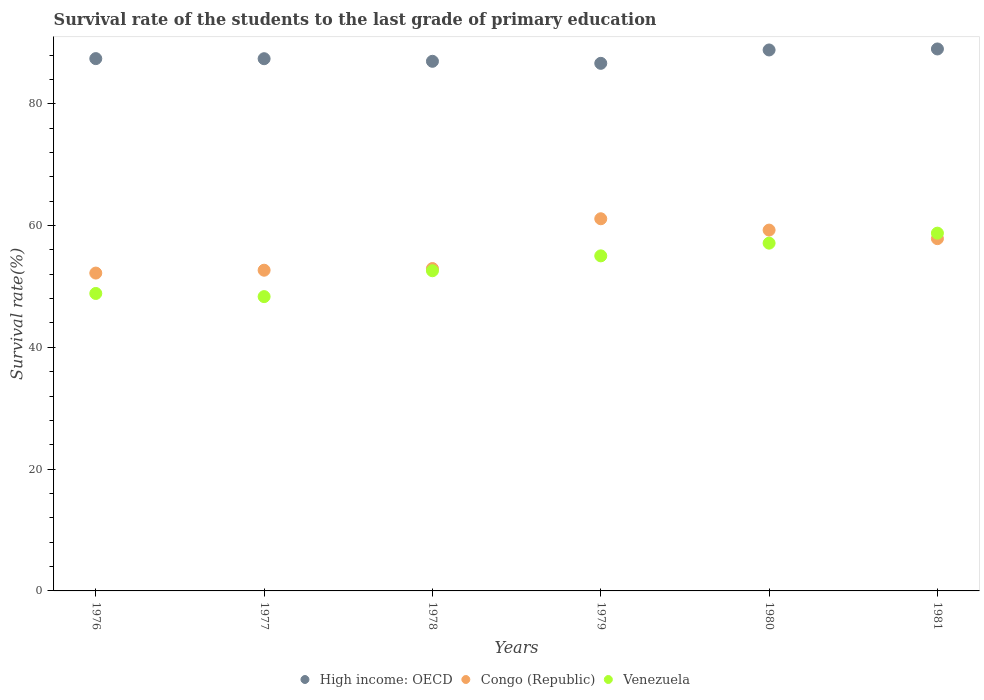How many different coloured dotlines are there?
Make the answer very short. 3. Is the number of dotlines equal to the number of legend labels?
Offer a terse response. Yes. What is the survival rate of the students in Congo (Republic) in 1978?
Ensure brevity in your answer.  52.94. Across all years, what is the maximum survival rate of the students in Congo (Republic)?
Ensure brevity in your answer.  61.11. Across all years, what is the minimum survival rate of the students in Venezuela?
Your response must be concise. 48.33. In which year was the survival rate of the students in Venezuela maximum?
Your response must be concise. 1981. In which year was the survival rate of the students in High income: OECD minimum?
Give a very brief answer. 1979. What is the total survival rate of the students in Congo (Republic) in the graph?
Provide a short and direct response. 336. What is the difference between the survival rate of the students in High income: OECD in 1978 and that in 1980?
Make the answer very short. -1.86. What is the difference between the survival rate of the students in High income: OECD in 1981 and the survival rate of the students in Congo (Republic) in 1978?
Ensure brevity in your answer.  36.06. What is the average survival rate of the students in Venezuela per year?
Your answer should be very brief. 53.44. In the year 1976, what is the difference between the survival rate of the students in Congo (Republic) and survival rate of the students in High income: OECD?
Make the answer very short. -35.22. In how many years, is the survival rate of the students in Congo (Republic) greater than 76 %?
Give a very brief answer. 0. What is the ratio of the survival rate of the students in Congo (Republic) in 1978 to that in 1980?
Offer a terse response. 0.89. Is the survival rate of the students in Congo (Republic) in 1977 less than that in 1979?
Provide a short and direct response. Yes. What is the difference between the highest and the second highest survival rate of the students in Venezuela?
Offer a very short reply. 1.64. What is the difference between the highest and the lowest survival rate of the students in Venezuela?
Your answer should be very brief. 10.42. In how many years, is the survival rate of the students in High income: OECD greater than the average survival rate of the students in High income: OECD taken over all years?
Provide a succinct answer. 2. Is the sum of the survival rate of the students in Venezuela in 1979 and 1981 greater than the maximum survival rate of the students in High income: OECD across all years?
Your answer should be compact. Yes. Is it the case that in every year, the sum of the survival rate of the students in Venezuela and survival rate of the students in Congo (Republic)  is greater than the survival rate of the students in High income: OECD?
Your answer should be very brief. Yes. Is the survival rate of the students in Congo (Republic) strictly less than the survival rate of the students in Venezuela over the years?
Your response must be concise. No. Are the values on the major ticks of Y-axis written in scientific E-notation?
Give a very brief answer. No. How are the legend labels stacked?
Make the answer very short. Horizontal. What is the title of the graph?
Offer a very short reply. Survival rate of the students to the last grade of primary education. What is the label or title of the Y-axis?
Keep it short and to the point. Survival rate(%). What is the Survival rate(%) of High income: OECD in 1976?
Make the answer very short. 87.41. What is the Survival rate(%) in Congo (Republic) in 1976?
Provide a short and direct response. 52.19. What is the Survival rate(%) of Venezuela in 1976?
Ensure brevity in your answer.  48.85. What is the Survival rate(%) in High income: OECD in 1977?
Make the answer very short. 87.39. What is the Survival rate(%) in Congo (Republic) in 1977?
Your answer should be compact. 52.66. What is the Survival rate(%) in Venezuela in 1977?
Keep it short and to the point. 48.33. What is the Survival rate(%) in High income: OECD in 1978?
Your answer should be compact. 86.97. What is the Survival rate(%) of Congo (Republic) in 1978?
Provide a short and direct response. 52.94. What is the Survival rate(%) in Venezuela in 1978?
Offer a very short reply. 52.58. What is the Survival rate(%) in High income: OECD in 1979?
Your response must be concise. 86.63. What is the Survival rate(%) of Congo (Republic) in 1979?
Your answer should be compact. 61.11. What is the Survival rate(%) of Venezuela in 1979?
Your answer should be very brief. 55.02. What is the Survival rate(%) of High income: OECD in 1980?
Make the answer very short. 88.83. What is the Survival rate(%) of Congo (Republic) in 1980?
Provide a succinct answer. 59.25. What is the Survival rate(%) in Venezuela in 1980?
Your answer should be very brief. 57.11. What is the Survival rate(%) in High income: OECD in 1981?
Ensure brevity in your answer.  88.99. What is the Survival rate(%) of Congo (Republic) in 1981?
Make the answer very short. 57.85. What is the Survival rate(%) of Venezuela in 1981?
Offer a very short reply. 58.75. Across all years, what is the maximum Survival rate(%) of High income: OECD?
Make the answer very short. 88.99. Across all years, what is the maximum Survival rate(%) in Congo (Republic)?
Make the answer very short. 61.11. Across all years, what is the maximum Survival rate(%) in Venezuela?
Keep it short and to the point. 58.75. Across all years, what is the minimum Survival rate(%) in High income: OECD?
Your answer should be very brief. 86.63. Across all years, what is the minimum Survival rate(%) in Congo (Republic)?
Provide a succinct answer. 52.19. Across all years, what is the minimum Survival rate(%) of Venezuela?
Provide a short and direct response. 48.33. What is the total Survival rate(%) of High income: OECD in the graph?
Your answer should be compact. 526.23. What is the total Survival rate(%) of Congo (Republic) in the graph?
Ensure brevity in your answer.  336. What is the total Survival rate(%) of Venezuela in the graph?
Offer a terse response. 320.62. What is the difference between the Survival rate(%) in High income: OECD in 1976 and that in 1977?
Ensure brevity in your answer.  0.01. What is the difference between the Survival rate(%) of Congo (Republic) in 1976 and that in 1977?
Provide a succinct answer. -0.47. What is the difference between the Survival rate(%) in Venezuela in 1976 and that in 1977?
Offer a terse response. 0.52. What is the difference between the Survival rate(%) of High income: OECD in 1976 and that in 1978?
Provide a short and direct response. 0.44. What is the difference between the Survival rate(%) in Congo (Republic) in 1976 and that in 1978?
Provide a short and direct response. -0.74. What is the difference between the Survival rate(%) in Venezuela in 1976 and that in 1978?
Keep it short and to the point. -3.73. What is the difference between the Survival rate(%) of High income: OECD in 1976 and that in 1979?
Provide a succinct answer. 0.77. What is the difference between the Survival rate(%) of Congo (Republic) in 1976 and that in 1979?
Offer a terse response. -8.92. What is the difference between the Survival rate(%) in Venezuela in 1976 and that in 1979?
Provide a short and direct response. -6.17. What is the difference between the Survival rate(%) in High income: OECD in 1976 and that in 1980?
Offer a very short reply. -1.42. What is the difference between the Survival rate(%) of Congo (Republic) in 1976 and that in 1980?
Your answer should be compact. -7.06. What is the difference between the Survival rate(%) of Venezuela in 1976 and that in 1980?
Keep it short and to the point. -8.26. What is the difference between the Survival rate(%) in High income: OECD in 1976 and that in 1981?
Offer a terse response. -1.59. What is the difference between the Survival rate(%) of Congo (Republic) in 1976 and that in 1981?
Give a very brief answer. -5.65. What is the difference between the Survival rate(%) in Venezuela in 1976 and that in 1981?
Ensure brevity in your answer.  -9.9. What is the difference between the Survival rate(%) of High income: OECD in 1977 and that in 1978?
Your response must be concise. 0.43. What is the difference between the Survival rate(%) in Congo (Republic) in 1977 and that in 1978?
Your answer should be compact. -0.27. What is the difference between the Survival rate(%) of Venezuela in 1977 and that in 1978?
Offer a terse response. -4.25. What is the difference between the Survival rate(%) of High income: OECD in 1977 and that in 1979?
Your answer should be compact. 0.76. What is the difference between the Survival rate(%) of Congo (Republic) in 1977 and that in 1979?
Your answer should be compact. -8.45. What is the difference between the Survival rate(%) in Venezuela in 1977 and that in 1979?
Your answer should be compact. -6.69. What is the difference between the Survival rate(%) of High income: OECD in 1977 and that in 1980?
Offer a very short reply. -1.44. What is the difference between the Survival rate(%) in Congo (Republic) in 1977 and that in 1980?
Offer a very short reply. -6.59. What is the difference between the Survival rate(%) of Venezuela in 1977 and that in 1980?
Offer a very short reply. -8.78. What is the difference between the Survival rate(%) in High income: OECD in 1977 and that in 1981?
Offer a very short reply. -1.6. What is the difference between the Survival rate(%) of Congo (Republic) in 1977 and that in 1981?
Offer a terse response. -5.18. What is the difference between the Survival rate(%) in Venezuela in 1977 and that in 1981?
Provide a succinct answer. -10.42. What is the difference between the Survival rate(%) of High income: OECD in 1978 and that in 1979?
Your response must be concise. 0.33. What is the difference between the Survival rate(%) of Congo (Republic) in 1978 and that in 1979?
Make the answer very short. -8.18. What is the difference between the Survival rate(%) in Venezuela in 1978 and that in 1979?
Provide a succinct answer. -2.44. What is the difference between the Survival rate(%) of High income: OECD in 1978 and that in 1980?
Ensure brevity in your answer.  -1.86. What is the difference between the Survival rate(%) in Congo (Republic) in 1978 and that in 1980?
Offer a terse response. -6.31. What is the difference between the Survival rate(%) in Venezuela in 1978 and that in 1980?
Provide a succinct answer. -4.53. What is the difference between the Survival rate(%) of High income: OECD in 1978 and that in 1981?
Provide a succinct answer. -2.03. What is the difference between the Survival rate(%) in Congo (Republic) in 1978 and that in 1981?
Keep it short and to the point. -4.91. What is the difference between the Survival rate(%) of Venezuela in 1978 and that in 1981?
Your answer should be very brief. -6.17. What is the difference between the Survival rate(%) of High income: OECD in 1979 and that in 1980?
Offer a terse response. -2.2. What is the difference between the Survival rate(%) in Congo (Republic) in 1979 and that in 1980?
Provide a succinct answer. 1.86. What is the difference between the Survival rate(%) in Venezuela in 1979 and that in 1980?
Your answer should be compact. -2.09. What is the difference between the Survival rate(%) of High income: OECD in 1979 and that in 1981?
Offer a very short reply. -2.36. What is the difference between the Survival rate(%) of Congo (Republic) in 1979 and that in 1981?
Give a very brief answer. 3.27. What is the difference between the Survival rate(%) in Venezuela in 1979 and that in 1981?
Offer a terse response. -3.73. What is the difference between the Survival rate(%) in High income: OECD in 1980 and that in 1981?
Offer a terse response. -0.16. What is the difference between the Survival rate(%) of Congo (Republic) in 1980 and that in 1981?
Your response must be concise. 1.41. What is the difference between the Survival rate(%) of Venezuela in 1980 and that in 1981?
Offer a very short reply. -1.64. What is the difference between the Survival rate(%) of High income: OECD in 1976 and the Survival rate(%) of Congo (Republic) in 1977?
Provide a short and direct response. 34.75. What is the difference between the Survival rate(%) in High income: OECD in 1976 and the Survival rate(%) in Venezuela in 1977?
Offer a very short reply. 39.08. What is the difference between the Survival rate(%) of Congo (Republic) in 1976 and the Survival rate(%) of Venezuela in 1977?
Offer a very short reply. 3.87. What is the difference between the Survival rate(%) of High income: OECD in 1976 and the Survival rate(%) of Congo (Republic) in 1978?
Keep it short and to the point. 34.47. What is the difference between the Survival rate(%) in High income: OECD in 1976 and the Survival rate(%) in Venezuela in 1978?
Keep it short and to the point. 34.83. What is the difference between the Survival rate(%) in Congo (Republic) in 1976 and the Survival rate(%) in Venezuela in 1978?
Keep it short and to the point. -0.38. What is the difference between the Survival rate(%) in High income: OECD in 1976 and the Survival rate(%) in Congo (Republic) in 1979?
Ensure brevity in your answer.  26.3. What is the difference between the Survival rate(%) of High income: OECD in 1976 and the Survival rate(%) of Venezuela in 1979?
Offer a very short reply. 32.39. What is the difference between the Survival rate(%) of Congo (Republic) in 1976 and the Survival rate(%) of Venezuela in 1979?
Your answer should be very brief. -2.83. What is the difference between the Survival rate(%) in High income: OECD in 1976 and the Survival rate(%) in Congo (Republic) in 1980?
Make the answer very short. 28.16. What is the difference between the Survival rate(%) of High income: OECD in 1976 and the Survival rate(%) of Venezuela in 1980?
Offer a very short reply. 30.3. What is the difference between the Survival rate(%) in Congo (Republic) in 1976 and the Survival rate(%) in Venezuela in 1980?
Your response must be concise. -4.91. What is the difference between the Survival rate(%) of High income: OECD in 1976 and the Survival rate(%) of Congo (Republic) in 1981?
Offer a terse response. 29.56. What is the difference between the Survival rate(%) of High income: OECD in 1976 and the Survival rate(%) of Venezuela in 1981?
Your response must be concise. 28.66. What is the difference between the Survival rate(%) in Congo (Republic) in 1976 and the Survival rate(%) in Venezuela in 1981?
Offer a terse response. -6.56. What is the difference between the Survival rate(%) of High income: OECD in 1977 and the Survival rate(%) of Congo (Republic) in 1978?
Offer a terse response. 34.46. What is the difference between the Survival rate(%) in High income: OECD in 1977 and the Survival rate(%) in Venezuela in 1978?
Your answer should be compact. 34.82. What is the difference between the Survival rate(%) of Congo (Republic) in 1977 and the Survival rate(%) of Venezuela in 1978?
Ensure brevity in your answer.  0.09. What is the difference between the Survival rate(%) of High income: OECD in 1977 and the Survival rate(%) of Congo (Republic) in 1979?
Your response must be concise. 26.28. What is the difference between the Survival rate(%) in High income: OECD in 1977 and the Survival rate(%) in Venezuela in 1979?
Your response must be concise. 32.37. What is the difference between the Survival rate(%) in Congo (Republic) in 1977 and the Survival rate(%) in Venezuela in 1979?
Provide a short and direct response. -2.36. What is the difference between the Survival rate(%) in High income: OECD in 1977 and the Survival rate(%) in Congo (Republic) in 1980?
Provide a short and direct response. 28.14. What is the difference between the Survival rate(%) in High income: OECD in 1977 and the Survival rate(%) in Venezuela in 1980?
Your answer should be compact. 30.29. What is the difference between the Survival rate(%) in Congo (Republic) in 1977 and the Survival rate(%) in Venezuela in 1980?
Offer a terse response. -4.44. What is the difference between the Survival rate(%) of High income: OECD in 1977 and the Survival rate(%) of Congo (Republic) in 1981?
Keep it short and to the point. 29.55. What is the difference between the Survival rate(%) in High income: OECD in 1977 and the Survival rate(%) in Venezuela in 1981?
Provide a succinct answer. 28.65. What is the difference between the Survival rate(%) of Congo (Republic) in 1977 and the Survival rate(%) of Venezuela in 1981?
Offer a terse response. -6.09. What is the difference between the Survival rate(%) of High income: OECD in 1978 and the Survival rate(%) of Congo (Republic) in 1979?
Your answer should be compact. 25.86. What is the difference between the Survival rate(%) in High income: OECD in 1978 and the Survival rate(%) in Venezuela in 1979?
Provide a short and direct response. 31.95. What is the difference between the Survival rate(%) of Congo (Republic) in 1978 and the Survival rate(%) of Venezuela in 1979?
Keep it short and to the point. -2.08. What is the difference between the Survival rate(%) of High income: OECD in 1978 and the Survival rate(%) of Congo (Republic) in 1980?
Your answer should be very brief. 27.72. What is the difference between the Survival rate(%) of High income: OECD in 1978 and the Survival rate(%) of Venezuela in 1980?
Ensure brevity in your answer.  29.86. What is the difference between the Survival rate(%) in Congo (Republic) in 1978 and the Survival rate(%) in Venezuela in 1980?
Keep it short and to the point. -4.17. What is the difference between the Survival rate(%) in High income: OECD in 1978 and the Survival rate(%) in Congo (Republic) in 1981?
Ensure brevity in your answer.  29.12. What is the difference between the Survival rate(%) in High income: OECD in 1978 and the Survival rate(%) in Venezuela in 1981?
Your answer should be very brief. 28.22. What is the difference between the Survival rate(%) in Congo (Republic) in 1978 and the Survival rate(%) in Venezuela in 1981?
Offer a terse response. -5.81. What is the difference between the Survival rate(%) of High income: OECD in 1979 and the Survival rate(%) of Congo (Republic) in 1980?
Offer a very short reply. 27.38. What is the difference between the Survival rate(%) of High income: OECD in 1979 and the Survival rate(%) of Venezuela in 1980?
Give a very brief answer. 29.53. What is the difference between the Survival rate(%) in Congo (Republic) in 1979 and the Survival rate(%) in Venezuela in 1980?
Make the answer very short. 4.01. What is the difference between the Survival rate(%) of High income: OECD in 1979 and the Survival rate(%) of Congo (Republic) in 1981?
Offer a very short reply. 28.79. What is the difference between the Survival rate(%) of High income: OECD in 1979 and the Survival rate(%) of Venezuela in 1981?
Your response must be concise. 27.89. What is the difference between the Survival rate(%) of Congo (Republic) in 1979 and the Survival rate(%) of Venezuela in 1981?
Your response must be concise. 2.36. What is the difference between the Survival rate(%) of High income: OECD in 1980 and the Survival rate(%) of Congo (Republic) in 1981?
Offer a very short reply. 30.99. What is the difference between the Survival rate(%) of High income: OECD in 1980 and the Survival rate(%) of Venezuela in 1981?
Offer a terse response. 30.08. What is the difference between the Survival rate(%) in Congo (Republic) in 1980 and the Survival rate(%) in Venezuela in 1981?
Your response must be concise. 0.5. What is the average Survival rate(%) of High income: OECD per year?
Ensure brevity in your answer.  87.71. What is the average Survival rate(%) in Venezuela per year?
Give a very brief answer. 53.44. In the year 1976, what is the difference between the Survival rate(%) in High income: OECD and Survival rate(%) in Congo (Republic)?
Your response must be concise. 35.22. In the year 1976, what is the difference between the Survival rate(%) in High income: OECD and Survival rate(%) in Venezuela?
Your response must be concise. 38.56. In the year 1976, what is the difference between the Survival rate(%) of Congo (Republic) and Survival rate(%) of Venezuela?
Your response must be concise. 3.35. In the year 1977, what is the difference between the Survival rate(%) of High income: OECD and Survival rate(%) of Congo (Republic)?
Offer a terse response. 34.73. In the year 1977, what is the difference between the Survival rate(%) of High income: OECD and Survival rate(%) of Venezuela?
Offer a terse response. 39.07. In the year 1977, what is the difference between the Survival rate(%) of Congo (Republic) and Survival rate(%) of Venezuela?
Keep it short and to the point. 4.33. In the year 1978, what is the difference between the Survival rate(%) of High income: OECD and Survival rate(%) of Congo (Republic)?
Your answer should be very brief. 34.03. In the year 1978, what is the difference between the Survival rate(%) in High income: OECD and Survival rate(%) in Venezuela?
Your response must be concise. 34.39. In the year 1978, what is the difference between the Survival rate(%) of Congo (Republic) and Survival rate(%) of Venezuela?
Your answer should be very brief. 0.36. In the year 1979, what is the difference between the Survival rate(%) in High income: OECD and Survival rate(%) in Congo (Republic)?
Your response must be concise. 25.52. In the year 1979, what is the difference between the Survival rate(%) in High income: OECD and Survival rate(%) in Venezuela?
Give a very brief answer. 31.61. In the year 1979, what is the difference between the Survival rate(%) of Congo (Republic) and Survival rate(%) of Venezuela?
Keep it short and to the point. 6.09. In the year 1980, what is the difference between the Survival rate(%) of High income: OECD and Survival rate(%) of Congo (Republic)?
Give a very brief answer. 29.58. In the year 1980, what is the difference between the Survival rate(%) in High income: OECD and Survival rate(%) in Venezuela?
Keep it short and to the point. 31.72. In the year 1980, what is the difference between the Survival rate(%) in Congo (Republic) and Survival rate(%) in Venezuela?
Provide a succinct answer. 2.14. In the year 1981, what is the difference between the Survival rate(%) in High income: OECD and Survival rate(%) in Congo (Republic)?
Your response must be concise. 31.15. In the year 1981, what is the difference between the Survival rate(%) in High income: OECD and Survival rate(%) in Venezuela?
Offer a terse response. 30.25. In the year 1981, what is the difference between the Survival rate(%) in Congo (Republic) and Survival rate(%) in Venezuela?
Your answer should be compact. -0.9. What is the ratio of the Survival rate(%) of High income: OECD in 1976 to that in 1977?
Make the answer very short. 1. What is the ratio of the Survival rate(%) of Venezuela in 1976 to that in 1977?
Ensure brevity in your answer.  1.01. What is the ratio of the Survival rate(%) in Congo (Republic) in 1976 to that in 1978?
Your answer should be compact. 0.99. What is the ratio of the Survival rate(%) of Venezuela in 1976 to that in 1978?
Provide a short and direct response. 0.93. What is the ratio of the Survival rate(%) in High income: OECD in 1976 to that in 1979?
Make the answer very short. 1.01. What is the ratio of the Survival rate(%) in Congo (Republic) in 1976 to that in 1979?
Make the answer very short. 0.85. What is the ratio of the Survival rate(%) of Venezuela in 1976 to that in 1979?
Your response must be concise. 0.89. What is the ratio of the Survival rate(%) in High income: OECD in 1976 to that in 1980?
Offer a very short reply. 0.98. What is the ratio of the Survival rate(%) in Congo (Republic) in 1976 to that in 1980?
Your answer should be very brief. 0.88. What is the ratio of the Survival rate(%) in Venezuela in 1976 to that in 1980?
Your answer should be compact. 0.86. What is the ratio of the Survival rate(%) in High income: OECD in 1976 to that in 1981?
Ensure brevity in your answer.  0.98. What is the ratio of the Survival rate(%) in Congo (Republic) in 1976 to that in 1981?
Your answer should be compact. 0.9. What is the ratio of the Survival rate(%) in Venezuela in 1976 to that in 1981?
Provide a short and direct response. 0.83. What is the ratio of the Survival rate(%) in High income: OECD in 1977 to that in 1978?
Offer a terse response. 1. What is the ratio of the Survival rate(%) in Congo (Republic) in 1977 to that in 1978?
Provide a short and direct response. 0.99. What is the ratio of the Survival rate(%) of Venezuela in 1977 to that in 1978?
Offer a very short reply. 0.92. What is the ratio of the Survival rate(%) in High income: OECD in 1977 to that in 1979?
Make the answer very short. 1.01. What is the ratio of the Survival rate(%) of Congo (Republic) in 1977 to that in 1979?
Ensure brevity in your answer.  0.86. What is the ratio of the Survival rate(%) of Venezuela in 1977 to that in 1979?
Provide a short and direct response. 0.88. What is the ratio of the Survival rate(%) in High income: OECD in 1977 to that in 1980?
Provide a short and direct response. 0.98. What is the ratio of the Survival rate(%) in Congo (Republic) in 1977 to that in 1980?
Your answer should be very brief. 0.89. What is the ratio of the Survival rate(%) of Venezuela in 1977 to that in 1980?
Keep it short and to the point. 0.85. What is the ratio of the Survival rate(%) of Congo (Republic) in 1977 to that in 1981?
Keep it short and to the point. 0.91. What is the ratio of the Survival rate(%) in Venezuela in 1977 to that in 1981?
Give a very brief answer. 0.82. What is the ratio of the Survival rate(%) in Congo (Republic) in 1978 to that in 1979?
Your response must be concise. 0.87. What is the ratio of the Survival rate(%) of Venezuela in 1978 to that in 1979?
Keep it short and to the point. 0.96. What is the ratio of the Survival rate(%) of High income: OECD in 1978 to that in 1980?
Provide a succinct answer. 0.98. What is the ratio of the Survival rate(%) in Congo (Republic) in 1978 to that in 1980?
Give a very brief answer. 0.89. What is the ratio of the Survival rate(%) in Venezuela in 1978 to that in 1980?
Your answer should be compact. 0.92. What is the ratio of the Survival rate(%) in High income: OECD in 1978 to that in 1981?
Ensure brevity in your answer.  0.98. What is the ratio of the Survival rate(%) in Congo (Republic) in 1978 to that in 1981?
Provide a succinct answer. 0.92. What is the ratio of the Survival rate(%) in Venezuela in 1978 to that in 1981?
Keep it short and to the point. 0.89. What is the ratio of the Survival rate(%) in High income: OECD in 1979 to that in 1980?
Make the answer very short. 0.98. What is the ratio of the Survival rate(%) of Congo (Republic) in 1979 to that in 1980?
Your answer should be compact. 1.03. What is the ratio of the Survival rate(%) of Venezuela in 1979 to that in 1980?
Your response must be concise. 0.96. What is the ratio of the Survival rate(%) in High income: OECD in 1979 to that in 1981?
Your answer should be very brief. 0.97. What is the ratio of the Survival rate(%) in Congo (Republic) in 1979 to that in 1981?
Keep it short and to the point. 1.06. What is the ratio of the Survival rate(%) in Venezuela in 1979 to that in 1981?
Your response must be concise. 0.94. What is the ratio of the Survival rate(%) in Congo (Republic) in 1980 to that in 1981?
Your answer should be compact. 1.02. What is the ratio of the Survival rate(%) of Venezuela in 1980 to that in 1981?
Keep it short and to the point. 0.97. What is the difference between the highest and the second highest Survival rate(%) of High income: OECD?
Ensure brevity in your answer.  0.16. What is the difference between the highest and the second highest Survival rate(%) in Congo (Republic)?
Provide a short and direct response. 1.86. What is the difference between the highest and the second highest Survival rate(%) in Venezuela?
Make the answer very short. 1.64. What is the difference between the highest and the lowest Survival rate(%) of High income: OECD?
Keep it short and to the point. 2.36. What is the difference between the highest and the lowest Survival rate(%) of Congo (Republic)?
Your answer should be compact. 8.92. What is the difference between the highest and the lowest Survival rate(%) in Venezuela?
Keep it short and to the point. 10.42. 